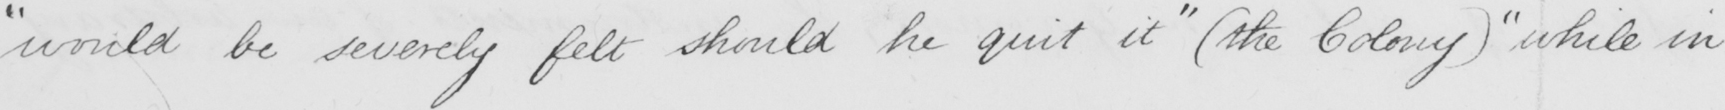Please provide the text content of this handwritten line. " would be severely felt should he quit it "   ( the Colony )  "  while in 